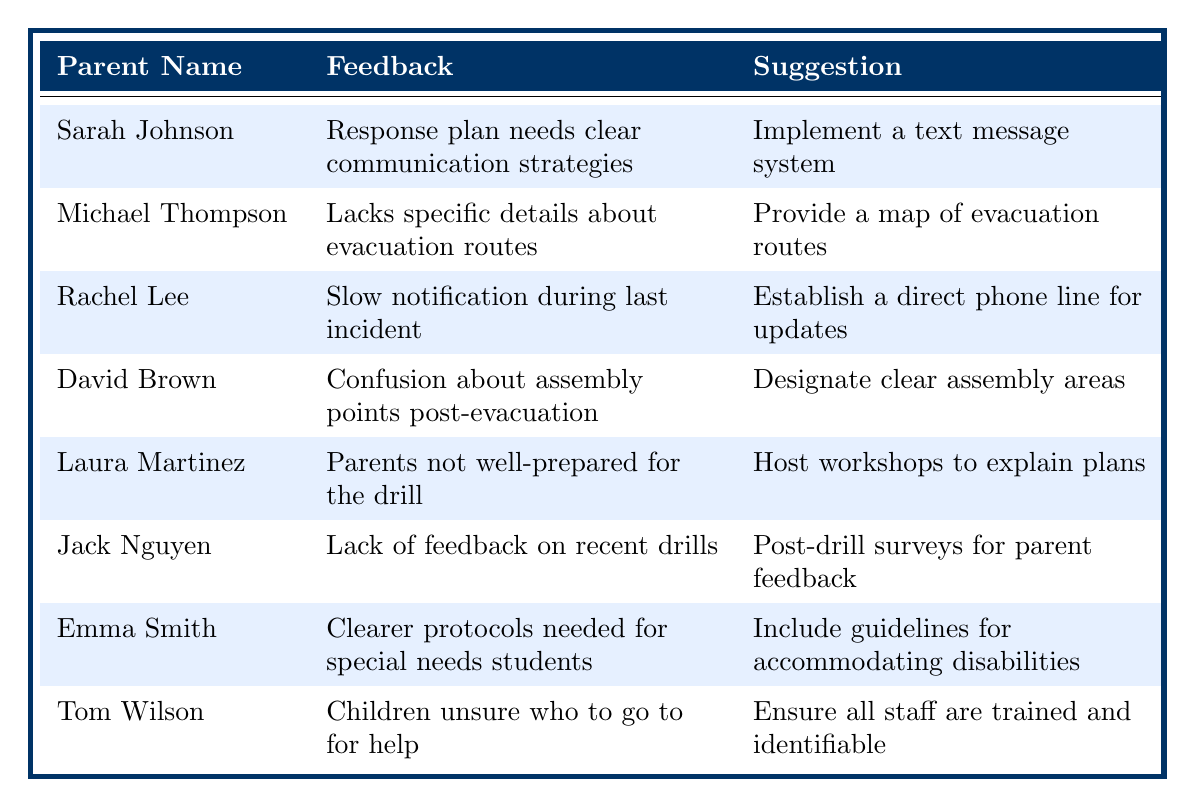What feedback did Sarah Johnson provide regarding the emergency response plan? Sarah Johnson stated that the response plan needs clear communication strategies, as many parents felt left in the dark during the last drill.
Answer: Clear communication strategies What suggestion did Michael Thompson make? Michael Thompson suggested providing a map of evacuation routes on the school website and in student handbooks.
Answer: Provide a map of evacuation routes How many parents expressed a need for better communication methods during emergencies? Three parents mentioned communication issues in their feedback. Sarah Johnson highlighted unclear communication, Rachel Lee mentioned slow notification, and Tom Wilson pointed out uncertainty among children regarding who to approach for help.
Answer: Three parents Did Laura Martinez suggest hosting workshops for parents? Yes, Laura Martinez suggested hosting workshops to explain the emergency response plans in detail.
Answer: Yes Which parent recommended establishing a direct phone line for updates? Rachel Lee recommended establishing a direct phone line for urgent updates that parents can call for information.
Answer: Rachel Lee What was the common concern across multiple parents regarding the emergency drills? The common concern was inadequate information and preparation for the drills, as expressed by Laura Martinez regarding readiness and Jack Nguyen about feedback.
Answer: Inadequate information and preparation Is there a suggestion for improving feedback after drills? Yes, Jack Nguyen suggested conducting post-drill surveys to gather parent feedback on the exercises conducted.
Answer: Yes Which suggestion involves staff training? Tom Wilson's suggestion involves ensuring all staff are trained and identifiable during emergency exercises.
Answer: Ensuring staff are trained and identifiable Is there a parent who mentioned the need for special protocols for students with disabilities? Yes, Emma Smith mentioned the need for clearer protocols for students with special needs during emergencies.
Answer: Yes What feedback did David Brown give about post-evacuation assembly points? David Brown expressed that there was confusion about assembly points after evacuation and raised concerns about supervision.
Answer: Confusion about assembly points and supervision concerns 